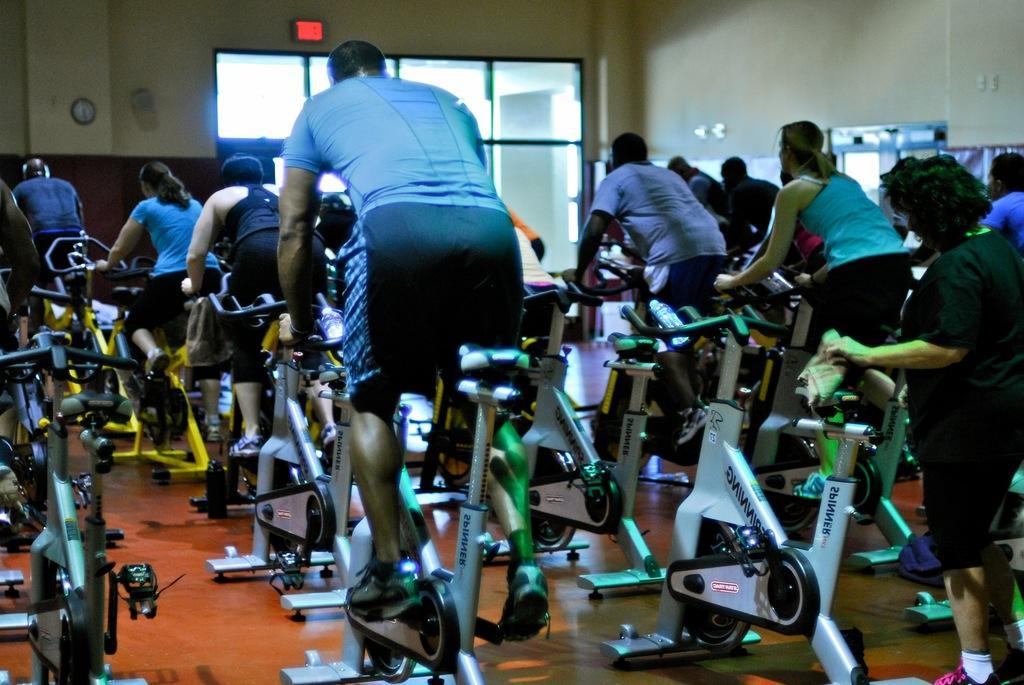In one or two sentences, can you explain what this image depicts? In this image I can see group of people riding bicycle. The person in front wearing black and blue color dress, background I can see few windows and a clock attached to the wall and the wall is in cream and brown color. 